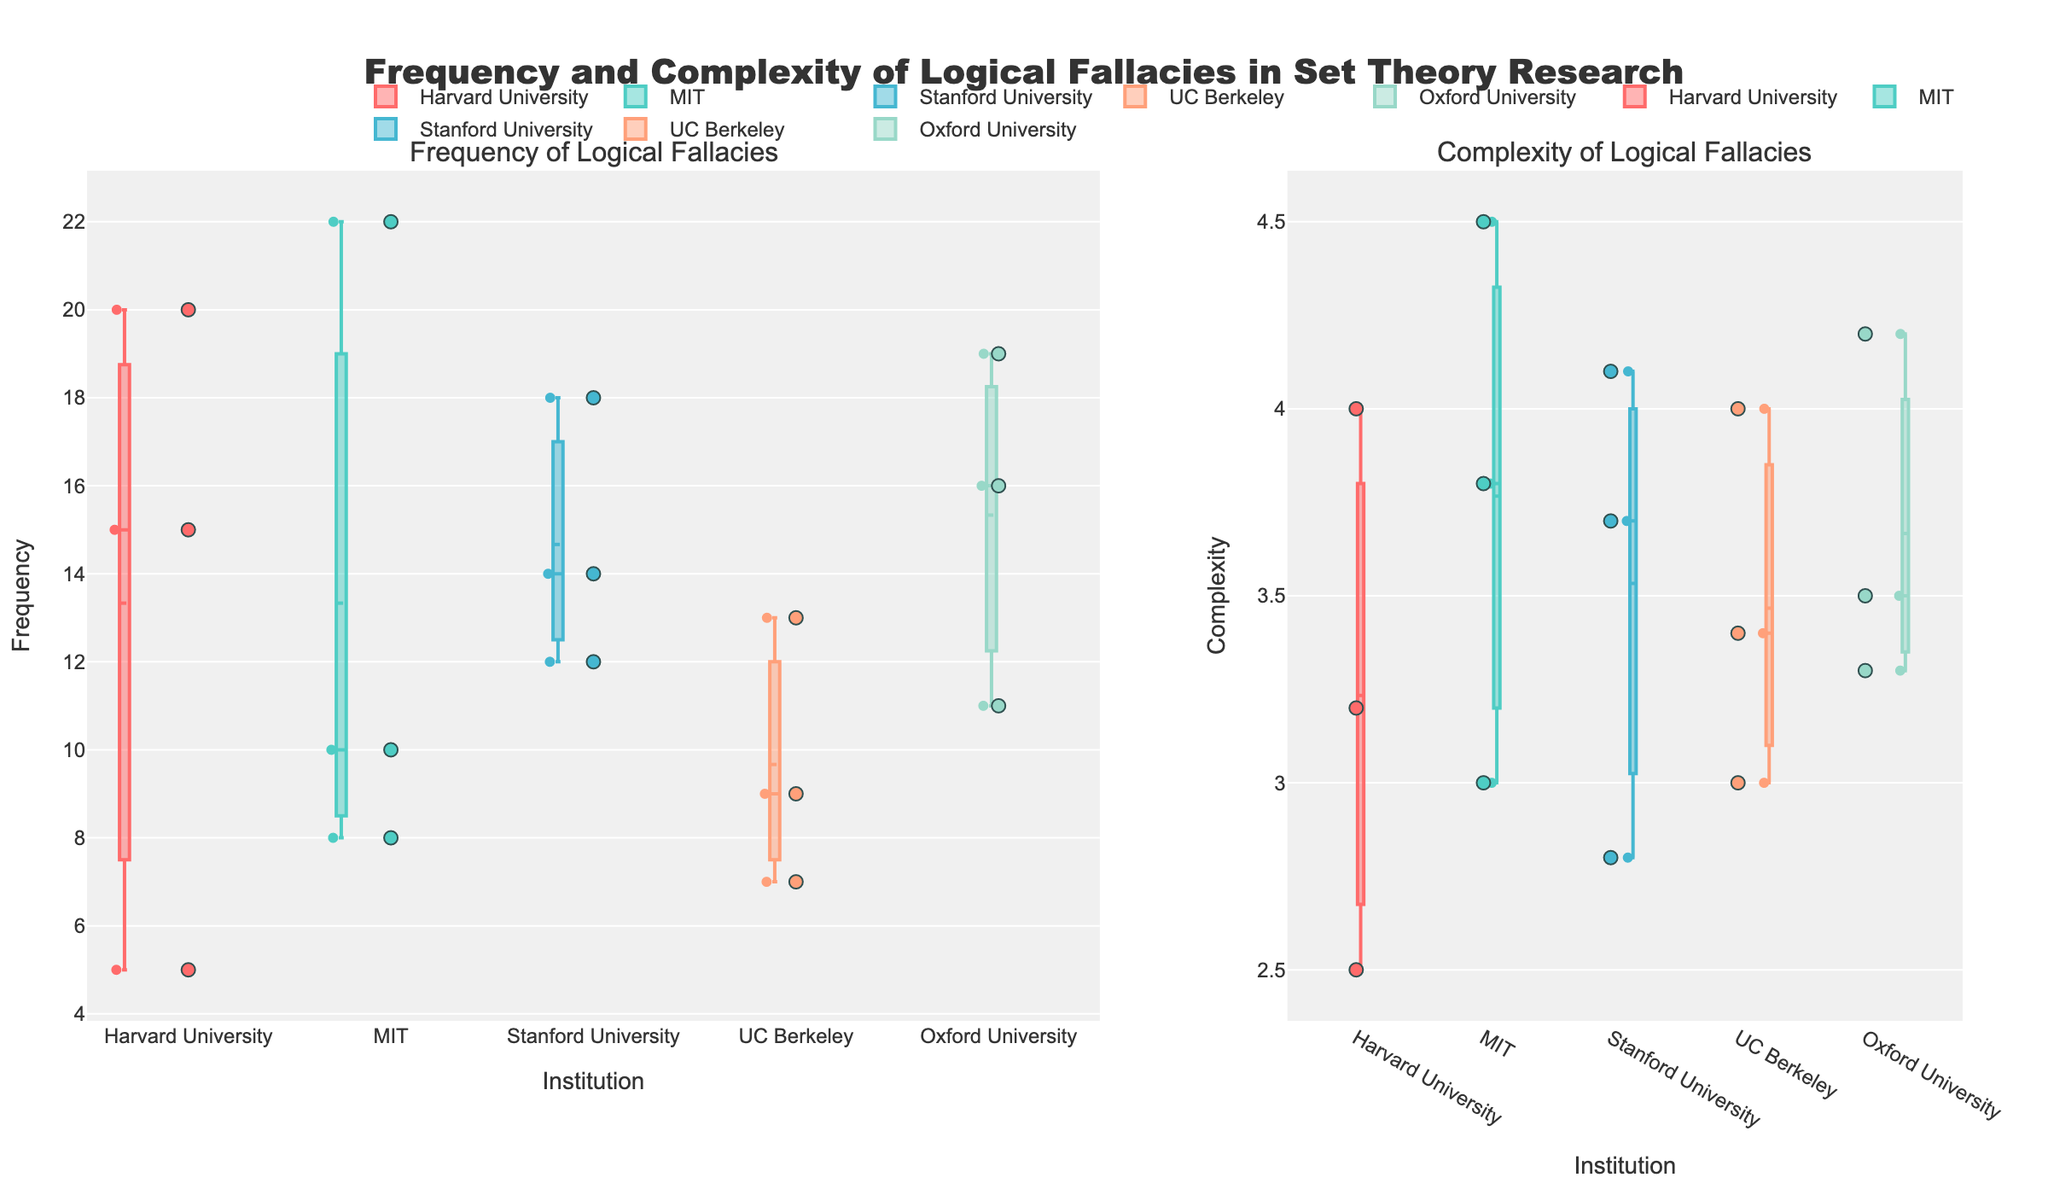What's the title of the figure? The title of the figure is displayed at the top and indicates the overall subject of the data being shown.
Answer: Frequency and Complexity of Logical Fallacies in Set Theory Research Which institution has the widest range in fallacy frequency? Harvard University has frequencies ranging from 5 to 20, showing the widest range from the smallest to largest values compared to other institutions.
Answer: Harvard University What is the median complexity value for UC Berkeley? In a box plot, the median is represented by the line inside the box. For UC Berkeley, the median complexity value can be observed as the horizontal line approximately at 3.4.
Answer: 3.4 Which institution has the highest single data point in fallacy complexity? By looking at the scatter points, we see that MIT has a single data point with a complexity of 4.5, which is the highest compared to all the other institutions.
Answer: MIT How does the median frequency of fallacies at Stanford University compare to that at MIT? The median frequency is the line within the box. Stanford University's median (14) appears higher than MIT's median (8).
Answer: Stanford University has a higher median frequency What is the interquartile range (IQR) of complexity values for Oxford University? The IQR is the distance between the first quartile (Q1) and the third quartile (Q3) values in the box plot. For Oxford University, Q1 is approximately 3.3, and Q3 is 4.2, thus IQR = 4.2 - 3.3 = 0.9.
Answer: 0.9 Which institution shows the lowest single data point in fallacy frequency? The lowest single data point is where the smallest marker is located. Harvard University shows a fallacy with a frequency of 5, which is the lowest among all institutions.
Answer: Harvard University What is the mean complexity value for Harvard University? In the combined box and scatter plot, the mean is indicated by a specific marker on the boxplot. For Harvard University, the mean complexity is located at around 3.3.
Answer: 3.3 Which institution has the most consistent frequency of fallacies (smallest range)? The consistency of data can be inferred from the narrowest range in boxplot whiskers. UC Berkeley shows the most consistent frequency with values between approximately 7 and 13.
Answer: UC Berkeley Which type of logical fallacy has the highest complexity value for MIT? The highest complexity value for MIT can be seen in the scatter points, where the Red Herring has the highest complexity value of 4.5.
Answer: Red Herring 